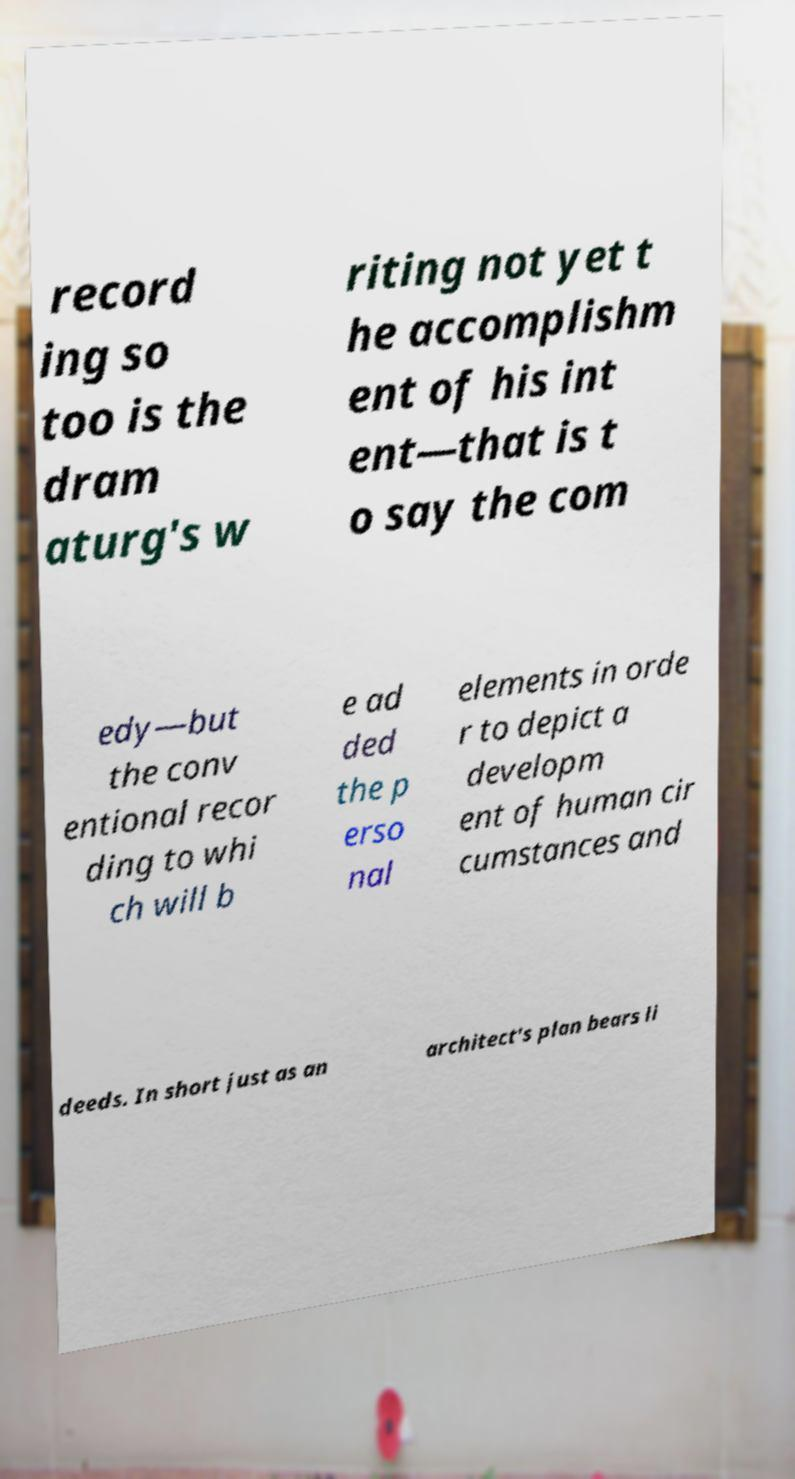For documentation purposes, I need the text within this image transcribed. Could you provide that? record ing so too is the dram aturg's w riting not yet t he accomplishm ent of his int ent—that is t o say the com edy—but the conv entional recor ding to whi ch will b e ad ded the p erso nal elements in orde r to depict a developm ent of human cir cumstances and deeds. In short just as an architect's plan bears li 